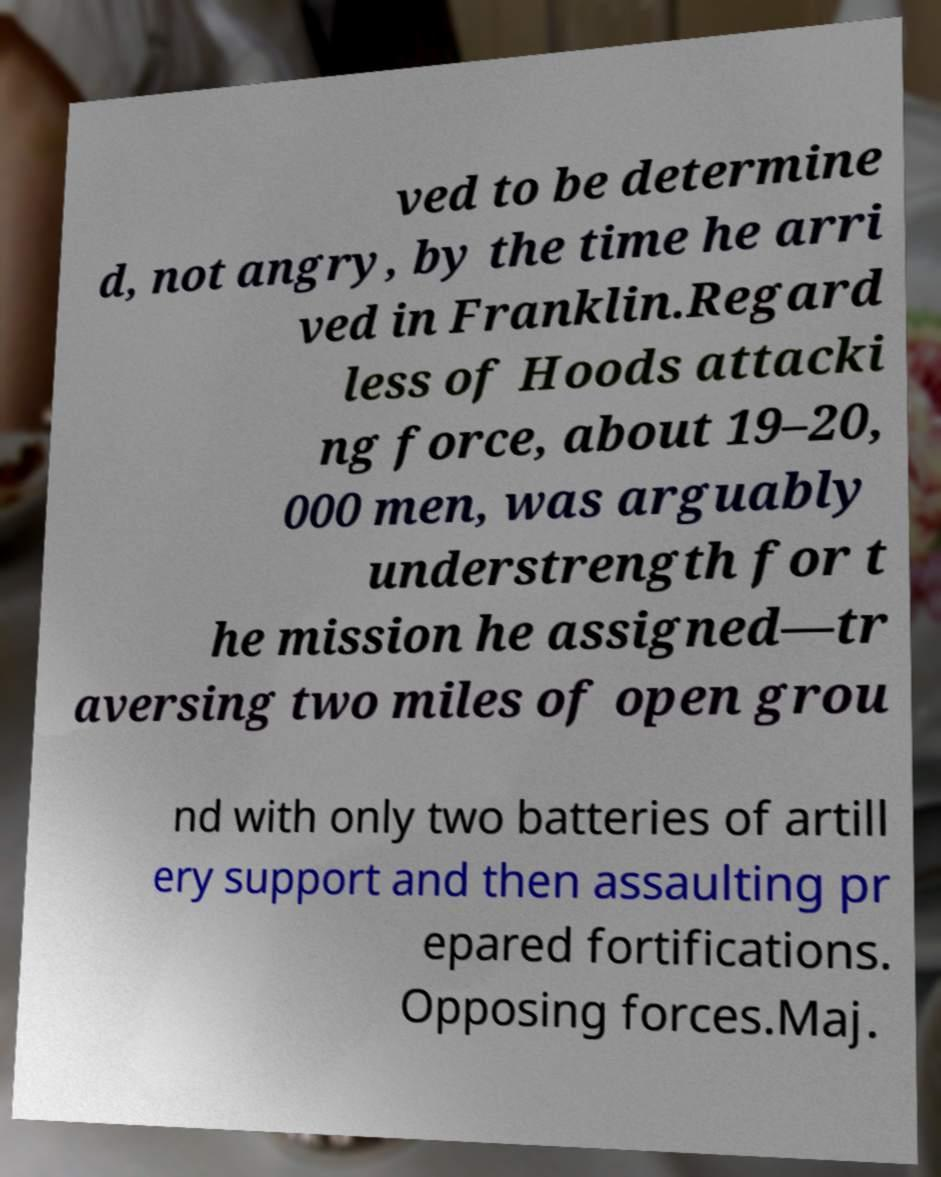For documentation purposes, I need the text within this image transcribed. Could you provide that? ved to be determine d, not angry, by the time he arri ved in Franklin.Regard less of Hoods attacki ng force, about 19–20, 000 men, was arguably understrength for t he mission he assigned—tr aversing two miles of open grou nd with only two batteries of artill ery support and then assaulting pr epared fortifications. Opposing forces.Maj. 